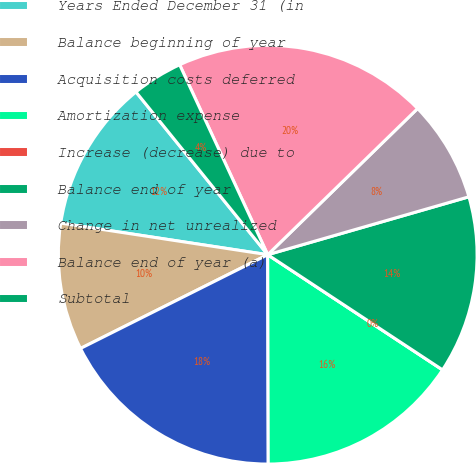Convert chart to OTSL. <chart><loc_0><loc_0><loc_500><loc_500><pie_chart><fcel>Years Ended December 31 (in<fcel>Balance beginning of year<fcel>Acquisition costs deferred<fcel>Amortization expense<fcel>Increase (decrease) due to<fcel>Balance end of year<fcel>Change in net unrealized<fcel>Balance end of year (a)<fcel>Subtotal<nl><fcel>11.76%<fcel>9.8%<fcel>17.65%<fcel>15.69%<fcel>0.0%<fcel>13.73%<fcel>7.84%<fcel>19.61%<fcel>3.92%<nl></chart> 